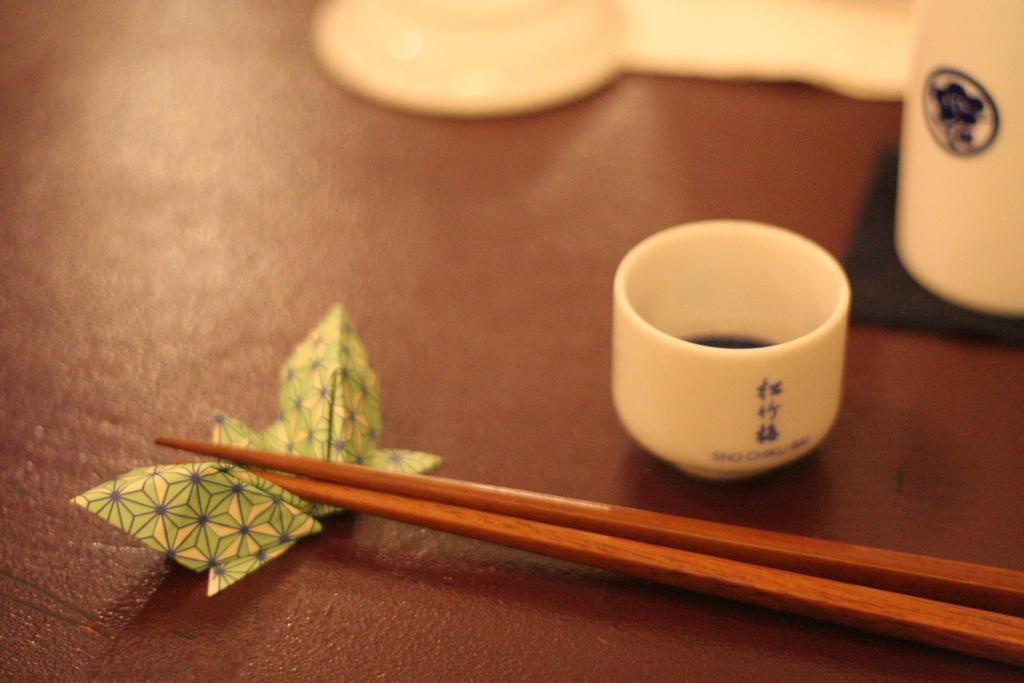Describe this image in one or two sentences. In this picture we can see a cup, glass, saucer, chopsticks on a paper butterfly and this all are placed on a table along with the cloth. 